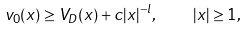<formula> <loc_0><loc_0><loc_500><loc_500>v _ { 0 } ( x ) \geq V _ { D } ( x ) + c | x | ^ { - l } , \quad | x | \geq 1 ,</formula> 